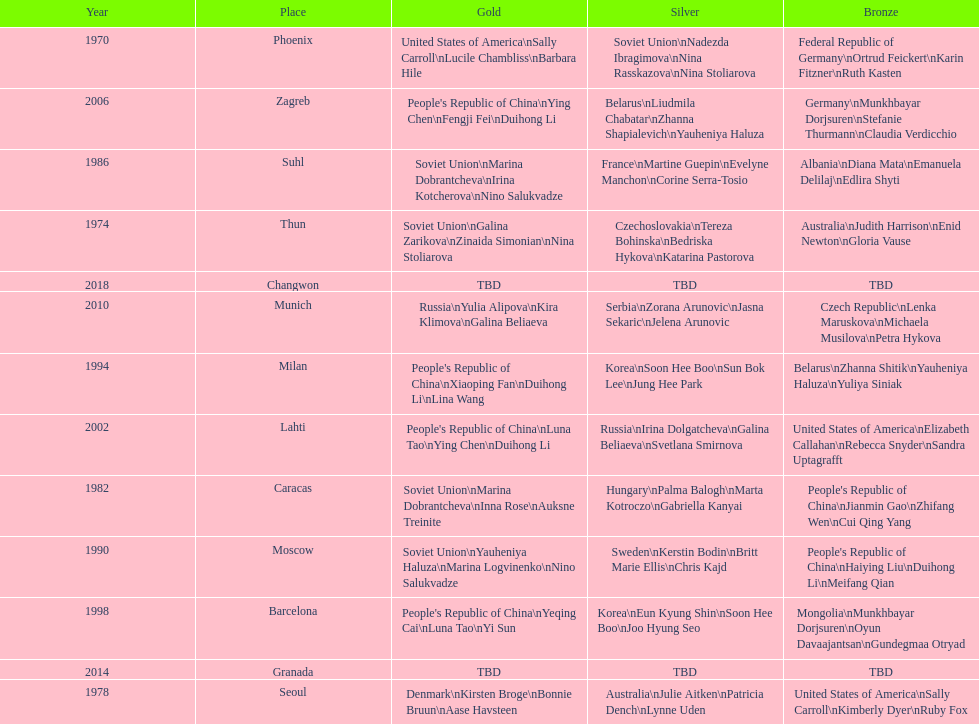What are the total number of times the soviet union is listed under the gold column? 4. 